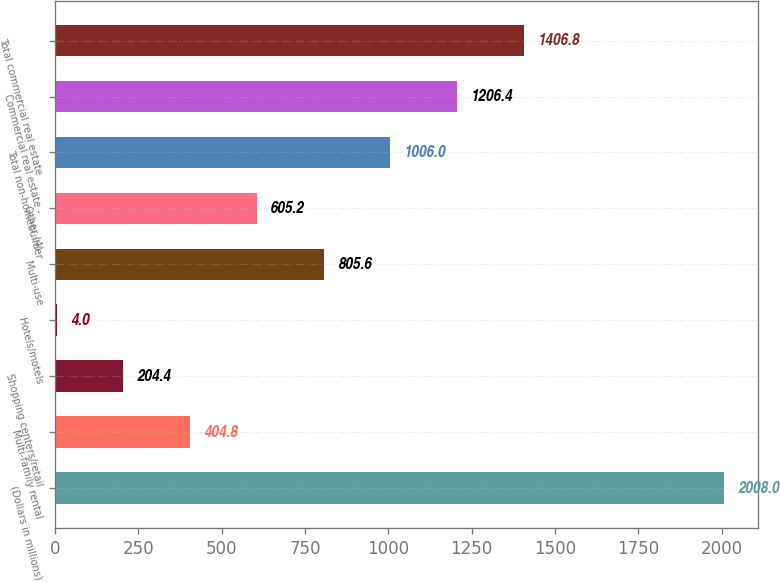Convert chart. <chart><loc_0><loc_0><loc_500><loc_500><bar_chart><fcel>(Dollars in millions)<fcel>Multi-family rental<fcel>Shopping centers/retail<fcel>Hotels/motels<fcel>Multi-use<fcel>Other (4)<fcel>Total non-homebuilder<fcel>Commercial real estate -<fcel>Total commercial real estate<nl><fcel>2008<fcel>404.8<fcel>204.4<fcel>4<fcel>805.6<fcel>605.2<fcel>1006<fcel>1206.4<fcel>1406.8<nl></chart> 